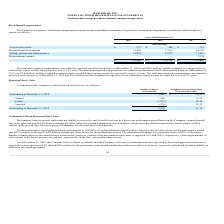From Maxlinear's financial document, What was the respective Selling, general and administrative expense in 2019, 2018 and 2017? The document contains multiple relevant values: 14,938, 13,279, 11,016 (in thousands). From the document: "Selling, general and administrative 14,938 13,279 11,016 Selling, general and administrative 14,938 13,279 11,016 Selling, general and administrative ..." Also, What was the respective research and development expense in 2019, 2018 and 2017? The document contains multiple relevant values: 16,545, 17,953, 16,190 (in thousands). From the document: "Research and development 16,545 17,953 16,190 Research and development 16,545 17,953 16,190 Research and development 16,545 17,953 16,190..." Also, What was the respective Cost of net revenue in 2019, 2018 and 2017? The document contains multiple relevant values: $577, $489, $332 (in thousands). From the document: "Cost of net revenue $ 577 $ 489 $ 332 Cost of net revenue $ 577 $ 489 $ 332 Cost of net revenue $ 577 $ 489 $ 332..." Also, can you calculate: What was the change in Cost of net revenue from 2018 to 2019? Based on the calculation: 577 - 489, the result is 88 (in thousands). This is based on the information: "Cost of net revenue $ 577 $ 489 $ 332 Cost of net revenue $ 577 $ 489 $ 332..." The key data points involved are: 489, 577. Also, can you calculate: What was the average Research and development between 2017-2019? To answer this question, I need to perform calculations using the financial data. The calculation is: (16,545 + 17,953 + 16,190) / 3, which equals 16896 (in thousands). This is based on the information: "Research and development 16,545 17,953 16,190 Research and development 16,545 17,953 16,190 Research and development 16,545 17,953 16,190..." The key data points involved are: 16,190, 16,545, 17,953. Additionally, In which year was Restructuring expense 0 thousands? The document shows two values: 2019 and 2018. Locate and analyze restructuring expense in row 7. From the document: "2019 2018 2017 2019 2018 2017..." 